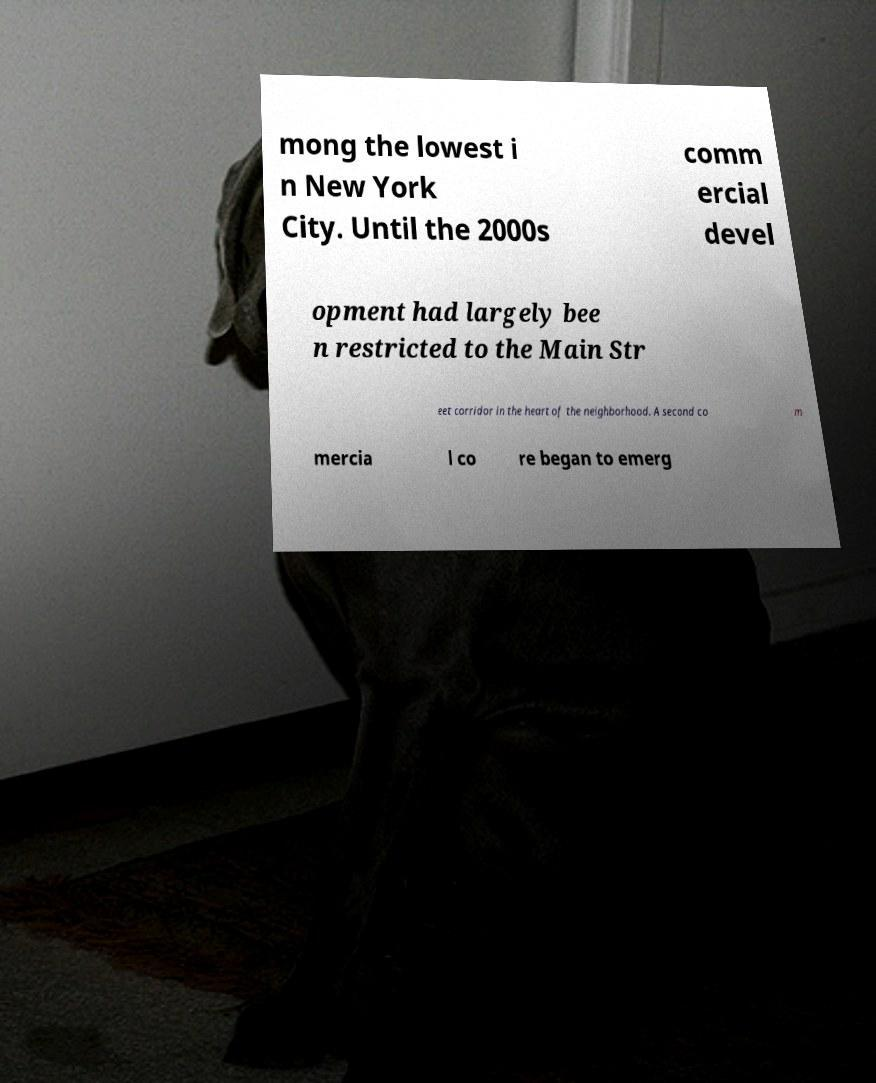Could you assist in decoding the text presented in this image and type it out clearly? mong the lowest i n New York City. Until the 2000s comm ercial devel opment had largely bee n restricted to the Main Str eet corridor in the heart of the neighborhood. A second co m mercia l co re began to emerg 